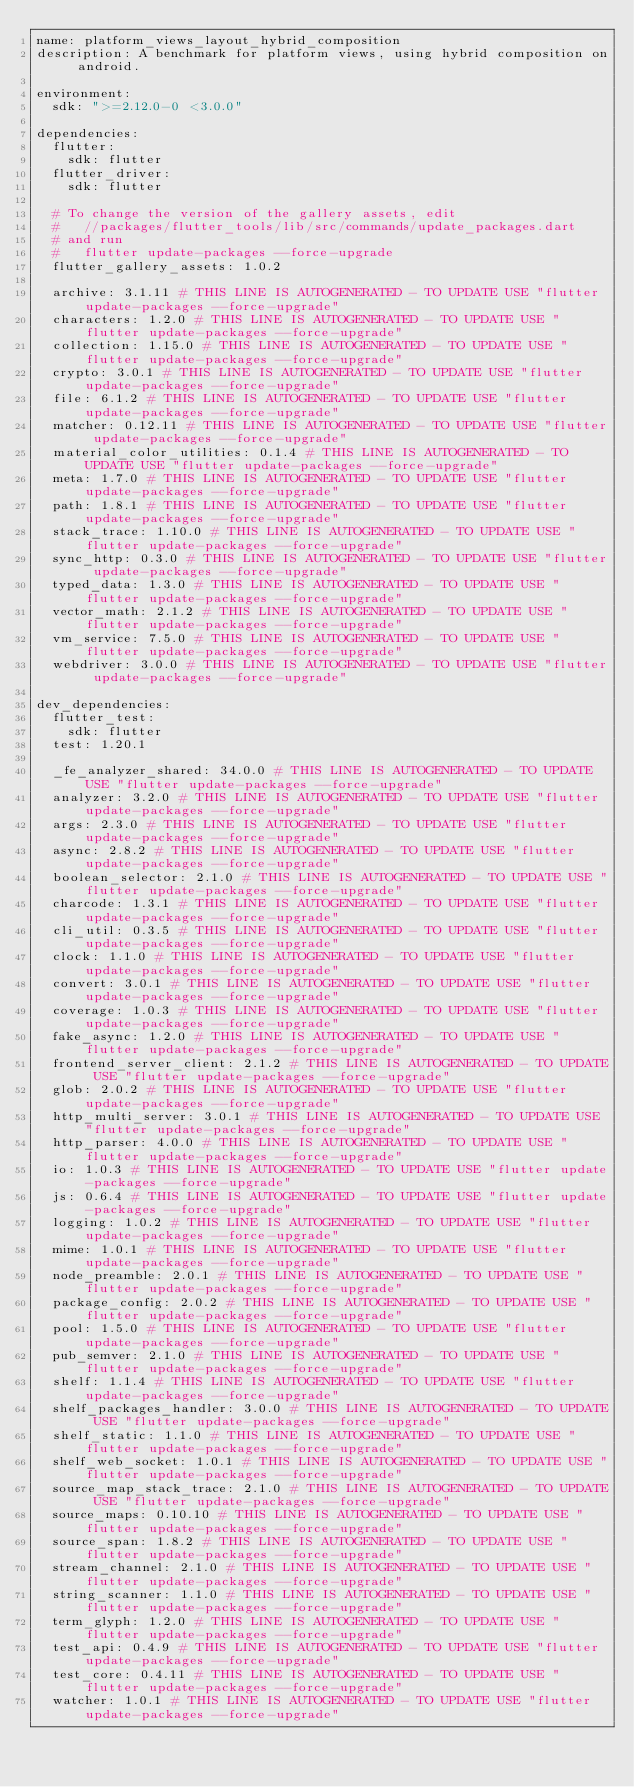Convert code to text. <code><loc_0><loc_0><loc_500><loc_500><_YAML_>name: platform_views_layout_hybrid_composition
description: A benchmark for platform views, using hybrid composition on android.

environment:
  sdk: ">=2.12.0-0 <3.0.0"

dependencies:
  flutter:
    sdk: flutter
  flutter_driver:
    sdk: flutter

  # To change the version of the gallery assets, edit
  #   //packages/flutter_tools/lib/src/commands/update_packages.dart
  # and run
  #   flutter update-packages --force-upgrade
  flutter_gallery_assets: 1.0.2

  archive: 3.1.11 # THIS LINE IS AUTOGENERATED - TO UPDATE USE "flutter update-packages --force-upgrade"
  characters: 1.2.0 # THIS LINE IS AUTOGENERATED - TO UPDATE USE "flutter update-packages --force-upgrade"
  collection: 1.15.0 # THIS LINE IS AUTOGENERATED - TO UPDATE USE "flutter update-packages --force-upgrade"
  crypto: 3.0.1 # THIS LINE IS AUTOGENERATED - TO UPDATE USE "flutter update-packages --force-upgrade"
  file: 6.1.2 # THIS LINE IS AUTOGENERATED - TO UPDATE USE "flutter update-packages --force-upgrade"
  matcher: 0.12.11 # THIS LINE IS AUTOGENERATED - TO UPDATE USE "flutter update-packages --force-upgrade"
  material_color_utilities: 0.1.4 # THIS LINE IS AUTOGENERATED - TO UPDATE USE "flutter update-packages --force-upgrade"
  meta: 1.7.0 # THIS LINE IS AUTOGENERATED - TO UPDATE USE "flutter update-packages --force-upgrade"
  path: 1.8.1 # THIS LINE IS AUTOGENERATED - TO UPDATE USE "flutter update-packages --force-upgrade"
  stack_trace: 1.10.0 # THIS LINE IS AUTOGENERATED - TO UPDATE USE "flutter update-packages --force-upgrade"
  sync_http: 0.3.0 # THIS LINE IS AUTOGENERATED - TO UPDATE USE "flutter update-packages --force-upgrade"
  typed_data: 1.3.0 # THIS LINE IS AUTOGENERATED - TO UPDATE USE "flutter update-packages --force-upgrade"
  vector_math: 2.1.2 # THIS LINE IS AUTOGENERATED - TO UPDATE USE "flutter update-packages --force-upgrade"
  vm_service: 7.5.0 # THIS LINE IS AUTOGENERATED - TO UPDATE USE "flutter update-packages --force-upgrade"
  webdriver: 3.0.0 # THIS LINE IS AUTOGENERATED - TO UPDATE USE "flutter update-packages --force-upgrade"

dev_dependencies:
  flutter_test:
    sdk: flutter
  test: 1.20.1

  _fe_analyzer_shared: 34.0.0 # THIS LINE IS AUTOGENERATED - TO UPDATE USE "flutter update-packages --force-upgrade"
  analyzer: 3.2.0 # THIS LINE IS AUTOGENERATED - TO UPDATE USE "flutter update-packages --force-upgrade"
  args: 2.3.0 # THIS LINE IS AUTOGENERATED - TO UPDATE USE "flutter update-packages --force-upgrade"
  async: 2.8.2 # THIS LINE IS AUTOGENERATED - TO UPDATE USE "flutter update-packages --force-upgrade"
  boolean_selector: 2.1.0 # THIS LINE IS AUTOGENERATED - TO UPDATE USE "flutter update-packages --force-upgrade"
  charcode: 1.3.1 # THIS LINE IS AUTOGENERATED - TO UPDATE USE "flutter update-packages --force-upgrade"
  cli_util: 0.3.5 # THIS LINE IS AUTOGENERATED - TO UPDATE USE "flutter update-packages --force-upgrade"
  clock: 1.1.0 # THIS LINE IS AUTOGENERATED - TO UPDATE USE "flutter update-packages --force-upgrade"
  convert: 3.0.1 # THIS LINE IS AUTOGENERATED - TO UPDATE USE "flutter update-packages --force-upgrade"
  coverage: 1.0.3 # THIS LINE IS AUTOGENERATED - TO UPDATE USE "flutter update-packages --force-upgrade"
  fake_async: 1.2.0 # THIS LINE IS AUTOGENERATED - TO UPDATE USE "flutter update-packages --force-upgrade"
  frontend_server_client: 2.1.2 # THIS LINE IS AUTOGENERATED - TO UPDATE USE "flutter update-packages --force-upgrade"
  glob: 2.0.2 # THIS LINE IS AUTOGENERATED - TO UPDATE USE "flutter update-packages --force-upgrade"
  http_multi_server: 3.0.1 # THIS LINE IS AUTOGENERATED - TO UPDATE USE "flutter update-packages --force-upgrade"
  http_parser: 4.0.0 # THIS LINE IS AUTOGENERATED - TO UPDATE USE "flutter update-packages --force-upgrade"
  io: 1.0.3 # THIS LINE IS AUTOGENERATED - TO UPDATE USE "flutter update-packages --force-upgrade"
  js: 0.6.4 # THIS LINE IS AUTOGENERATED - TO UPDATE USE "flutter update-packages --force-upgrade"
  logging: 1.0.2 # THIS LINE IS AUTOGENERATED - TO UPDATE USE "flutter update-packages --force-upgrade"
  mime: 1.0.1 # THIS LINE IS AUTOGENERATED - TO UPDATE USE "flutter update-packages --force-upgrade"
  node_preamble: 2.0.1 # THIS LINE IS AUTOGENERATED - TO UPDATE USE "flutter update-packages --force-upgrade"
  package_config: 2.0.2 # THIS LINE IS AUTOGENERATED - TO UPDATE USE "flutter update-packages --force-upgrade"
  pool: 1.5.0 # THIS LINE IS AUTOGENERATED - TO UPDATE USE "flutter update-packages --force-upgrade"
  pub_semver: 2.1.0 # THIS LINE IS AUTOGENERATED - TO UPDATE USE "flutter update-packages --force-upgrade"
  shelf: 1.1.4 # THIS LINE IS AUTOGENERATED - TO UPDATE USE "flutter update-packages --force-upgrade"
  shelf_packages_handler: 3.0.0 # THIS LINE IS AUTOGENERATED - TO UPDATE USE "flutter update-packages --force-upgrade"
  shelf_static: 1.1.0 # THIS LINE IS AUTOGENERATED - TO UPDATE USE "flutter update-packages --force-upgrade"
  shelf_web_socket: 1.0.1 # THIS LINE IS AUTOGENERATED - TO UPDATE USE "flutter update-packages --force-upgrade"
  source_map_stack_trace: 2.1.0 # THIS LINE IS AUTOGENERATED - TO UPDATE USE "flutter update-packages --force-upgrade"
  source_maps: 0.10.10 # THIS LINE IS AUTOGENERATED - TO UPDATE USE "flutter update-packages --force-upgrade"
  source_span: 1.8.2 # THIS LINE IS AUTOGENERATED - TO UPDATE USE "flutter update-packages --force-upgrade"
  stream_channel: 2.1.0 # THIS LINE IS AUTOGENERATED - TO UPDATE USE "flutter update-packages --force-upgrade"
  string_scanner: 1.1.0 # THIS LINE IS AUTOGENERATED - TO UPDATE USE "flutter update-packages --force-upgrade"
  term_glyph: 1.2.0 # THIS LINE IS AUTOGENERATED - TO UPDATE USE "flutter update-packages --force-upgrade"
  test_api: 0.4.9 # THIS LINE IS AUTOGENERATED - TO UPDATE USE "flutter update-packages --force-upgrade"
  test_core: 0.4.11 # THIS LINE IS AUTOGENERATED - TO UPDATE USE "flutter update-packages --force-upgrade"
  watcher: 1.0.1 # THIS LINE IS AUTOGENERATED - TO UPDATE USE "flutter update-packages --force-upgrade"</code> 